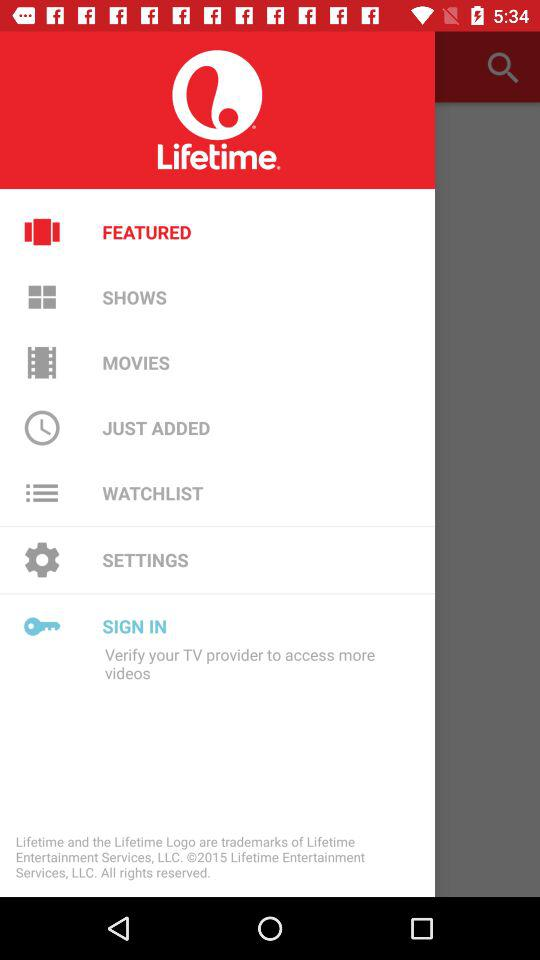What is the application name? The application name is "Lifetime". 